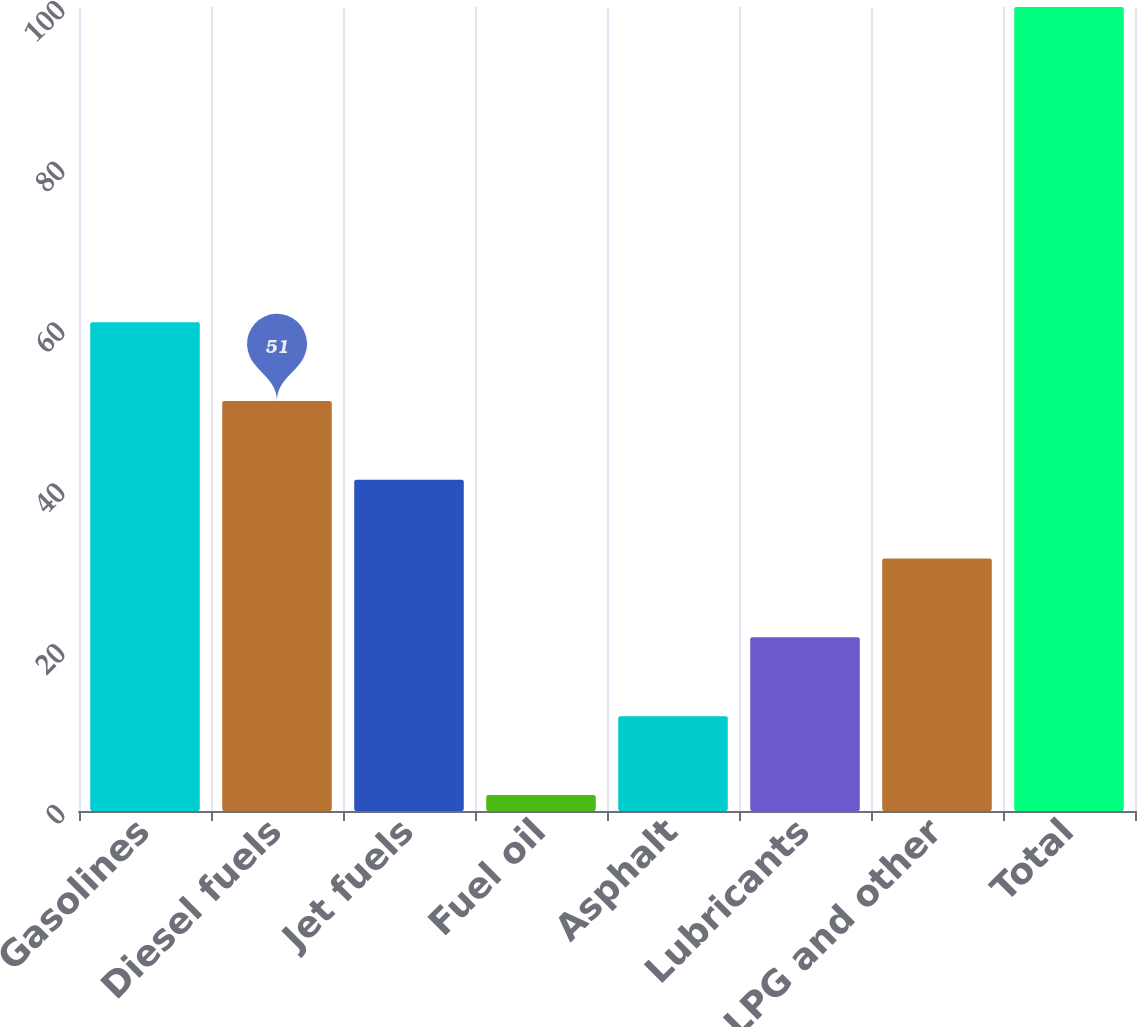<chart> <loc_0><loc_0><loc_500><loc_500><bar_chart><fcel>Gasolines<fcel>Diesel fuels<fcel>Jet fuels<fcel>Fuel oil<fcel>Asphalt<fcel>Lubricants<fcel>LPG and other<fcel>Total<nl><fcel>60.8<fcel>51<fcel>41.2<fcel>2<fcel>11.8<fcel>21.6<fcel>31.4<fcel>100<nl></chart> 